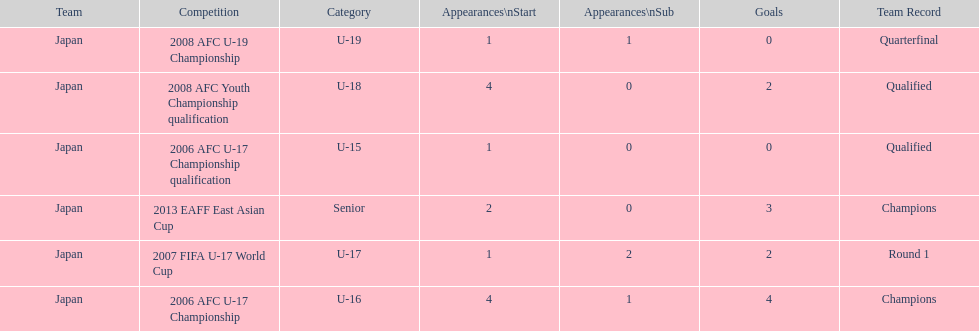Did japan have more starting appearances in the 2013 eaff east asian cup or 2007 fifa u-17 world cup? 2013 EAFF East Asian Cup. 